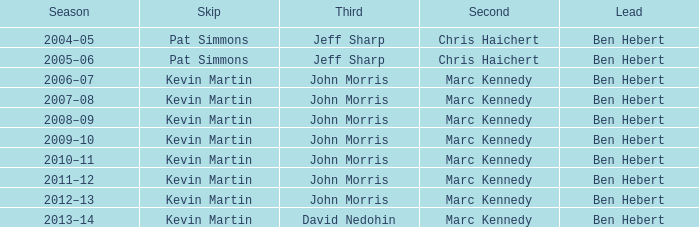What lead has the third David Nedohin? Ben Hebert. 